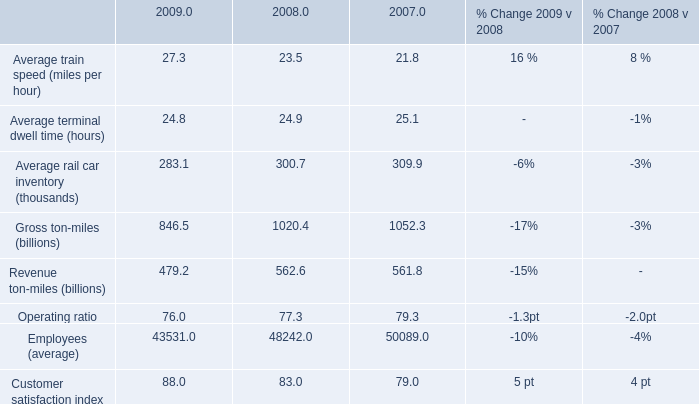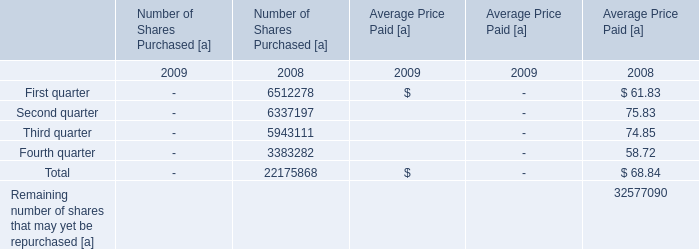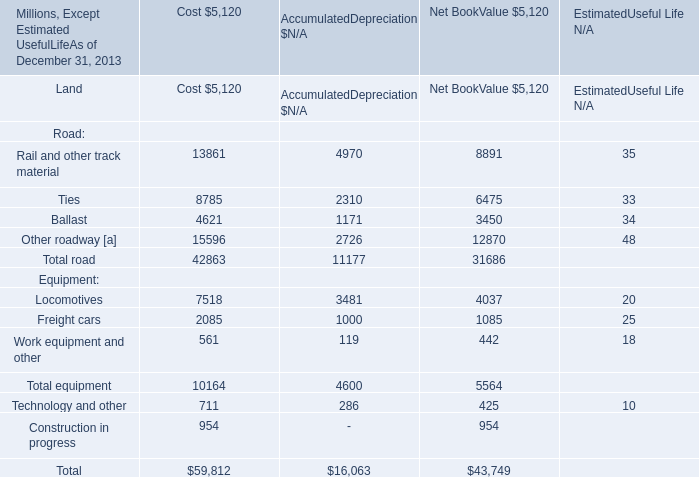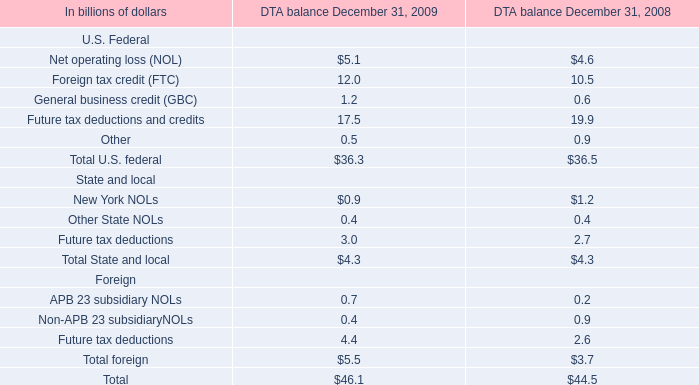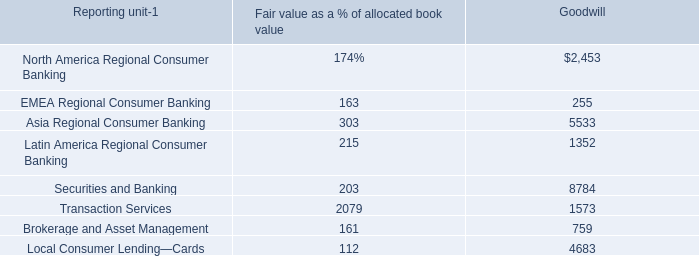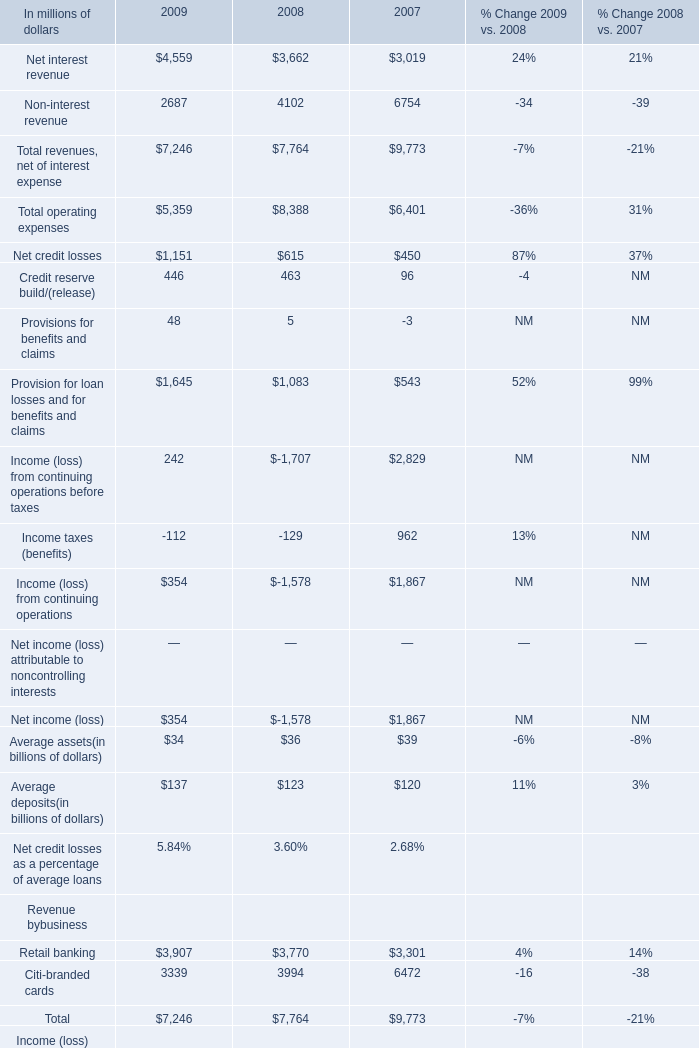What is the sum of the Total revenues, net of interest expense in the years where Income taxes (benefits) is positive? (in million) 
Computations: (3019 + 6754)
Answer: 9773.0. 